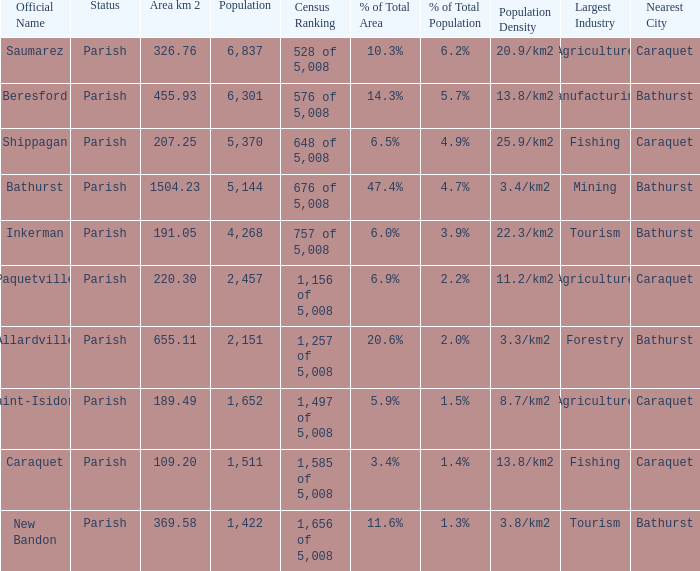What is the Area of the Saint-Isidore Parish with a Population smaller than 4,268? 189.49. 